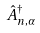Convert formula to latex. <formula><loc_0><loc_0><loc_500><loc_500>\hat { A } _ { n , \alpha } ^ { \dagger }</formula> 